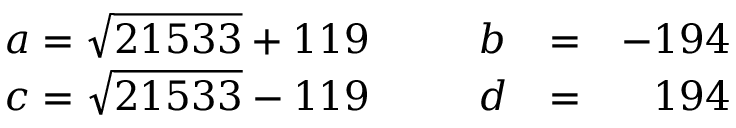Convert formula to latex. <formula><loc_0><loc_0><loc_500><loc_500>\begin{array} { l l l l r } { { a = \sqrt { 2 1 5 3 3 } + 1 1 9 \, } } & { \, } & { b } & { = } & { - 1 9 4 } \\ { { c = \sqrt { 2 1 5 3 3 } - 1 1 9 \, } } & { \, } & { d } & { = } & { 1 9 4 } \end{array}</formula> 